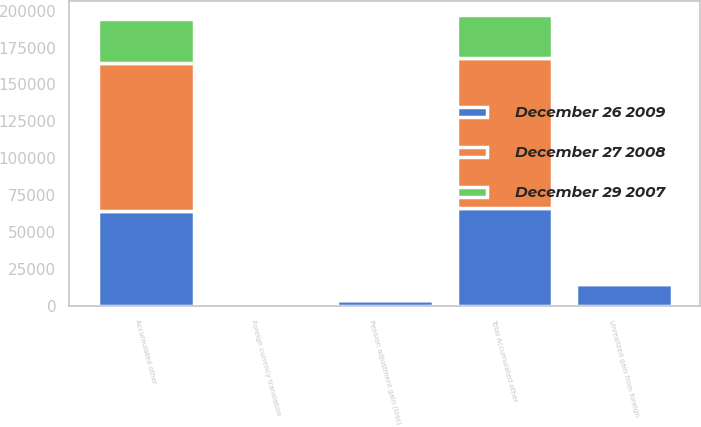<chart> <loc_0><loc_0><loc_500><loc_500><stacked_bar_chart><ecel><fcel>Foreign currency translation<fcel>Unrealized gain from foreign<fcel>Pension adjustment gain (loss)<fcel>Accumulated other<fcel>Total Accumulated other<nl><fcel>December 26 2009<fcel>1893<fcel>14537<fcel>3751<fcel>64194<fcel>66087<nl><fcel>December 29 2007<fcel>648<fcel>1220<fcel>379<fcel>29721<fcel>29073<nl><fcel>December 27 2008<fcel>1412<fcel>1134<fcel>391<fcel>100268<fcel>101680<nl></chart> 